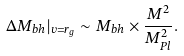Convert formula to latex. <formula><loc_0><loc_0><loc_500><loc_500>\Delta M _ { b h } | _ { v = r _ { g } } \sim M _ { b h } \times \frac { M ^ { 2 } } { M _ { P l } ^ { 2 } } .</formula> 